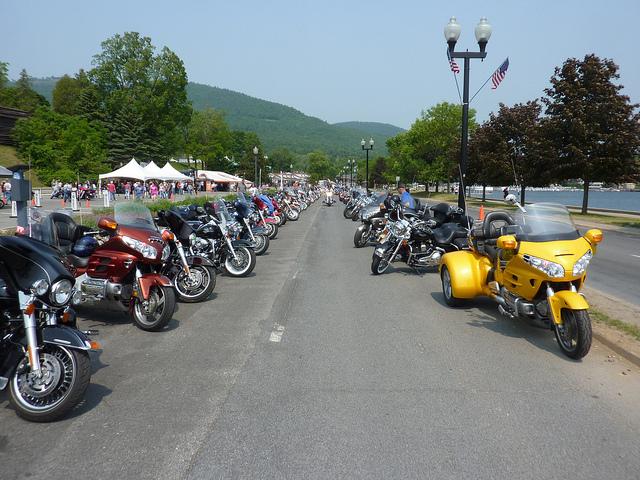How many wheels does the yellow bike have?
Answer briefly. 3. What country was this photo taken in?
Short answer required. Usa. Can you rent these bikes?
Quick response, please. No. How wide is the road?
Quick response, please. 20 feet. 